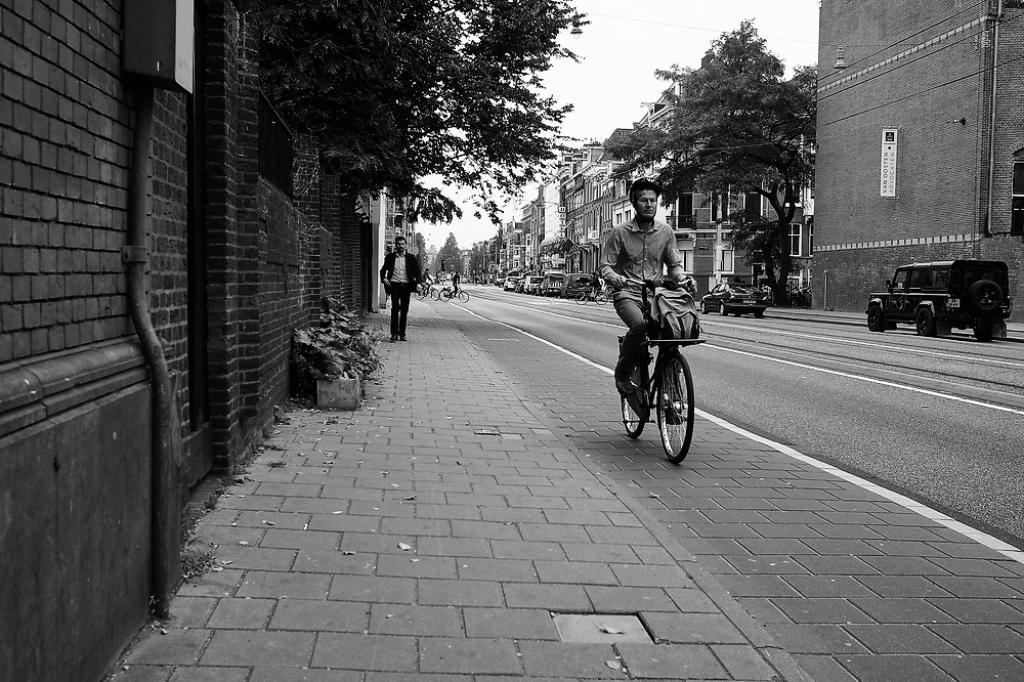What is the man in the image doing? The man is cycling on a bicycle in the image. What else can be seen on the road in the image? There are other vehicles on the road in the image. What type of structures are visible in the image? There are buildings visible in the image. What type of vegetation is present in the image? There are trees in the image. Can you see the man using a rifle in the image? No, there is no rifle present in the image. Is the man swimming in the image? No, the man is cycling on a bicycle, not swimming. 